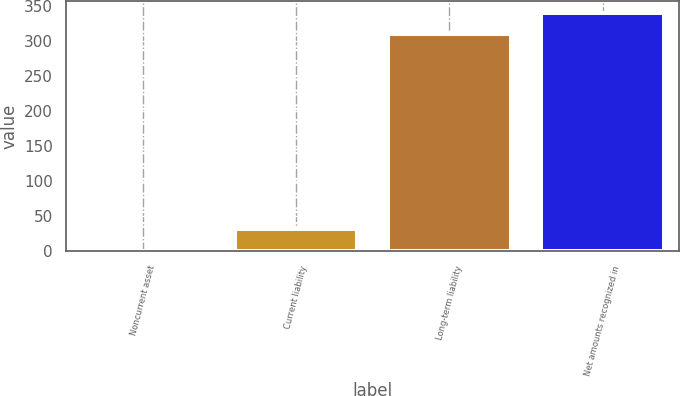Convert chart. <chart><loc_0><loc_0><loc_500><loc_500><bar_chart><fcel>Noncurrent asset<fcel>Current liability<fcel>Long-term liability<fcel>Net amounts recognized in<nl><fcel>1<fcel>32.3<fcel>309<fcel>340.3<nl></chart> 